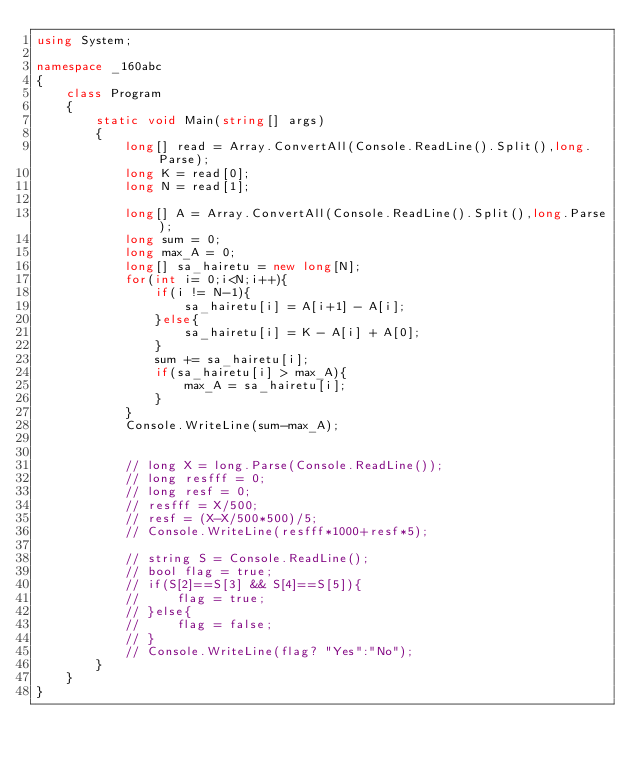Convert code to text. <code><loc_0><loc_0><loc_500><loc_500><_C#_>using System;

namespace _160abc
{
    class Program
    {
        static void Main(string[] args)
        {     
            long[] read = Array.ConvertAll(Console.ReadLine().Split(),long.Parse);
            long K = read[0];
            long N = read[1];

            long[] A = Array.ConvertAll(Console.ReadLine().Split(),long.Parse);
            long sum = 0;
            long max_A = 0;
            long[] sa_hairetu = new long[N];
            for(int i= 0;i<N;i++){
                if(i != N-1){
                    sa_hairetu[i] = A[i+1] - A[i];
                }else{
                    sa_hairetu[i] = K - A[i] + A[0];
                }
                sum += sa_hairetu[i];
                if(sa_hairetu[i] > max_A){
                    max_A = sa_hairetu[i];
                }
            }
            Console.WriteLine(sum-max_A);
            

            // long X = long.Parse(Console.ReadLine());
            // long resfff = 0;
            // long resf = 0;
            // resfff = X/500;
            // resf = (X-X/500*500)/5;
            // Console.WriteLine(resfff*1000+resf*5);

            // string S = Console.ReadLine();
            // bool flag = true;
            // if(S[2]==S[3] && S[4]==S[5]){
            //     flag = true;
            // }else{
            //     flag = false;
            // }
            // Console.WriteLine(flag? "Yes":"No");
        }
    }
}
</code> 